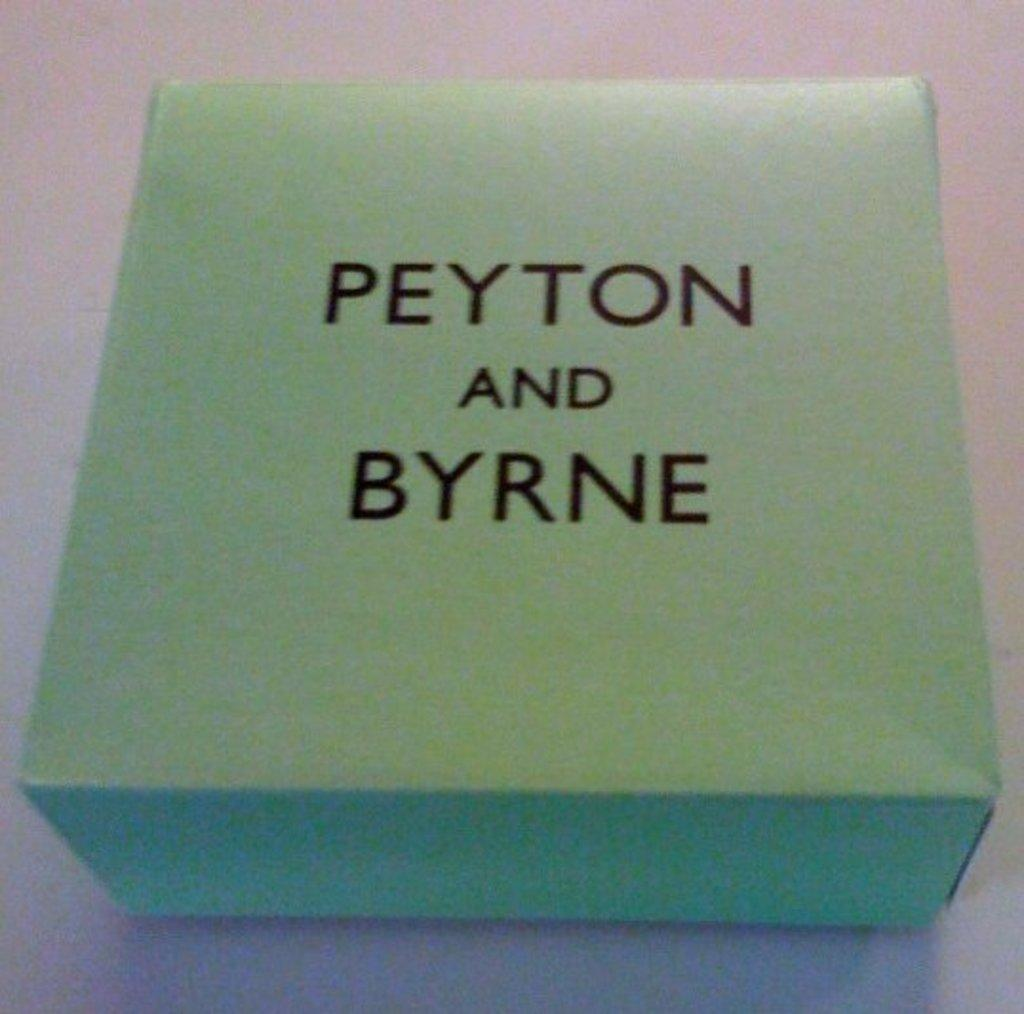Provide a one-sentence caption for the provided image. A green square box with the wording Peyton and Byrne. 